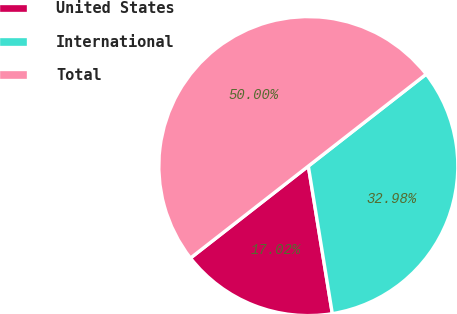<chart> <loc_0><loc_0><loc_500><loc_500><pie_chart><fcel>United States<fcel>International<fcel>Total<nl><fcel>17.02%<fcel>32.98%<fcel>50.0%<nl></chart> 